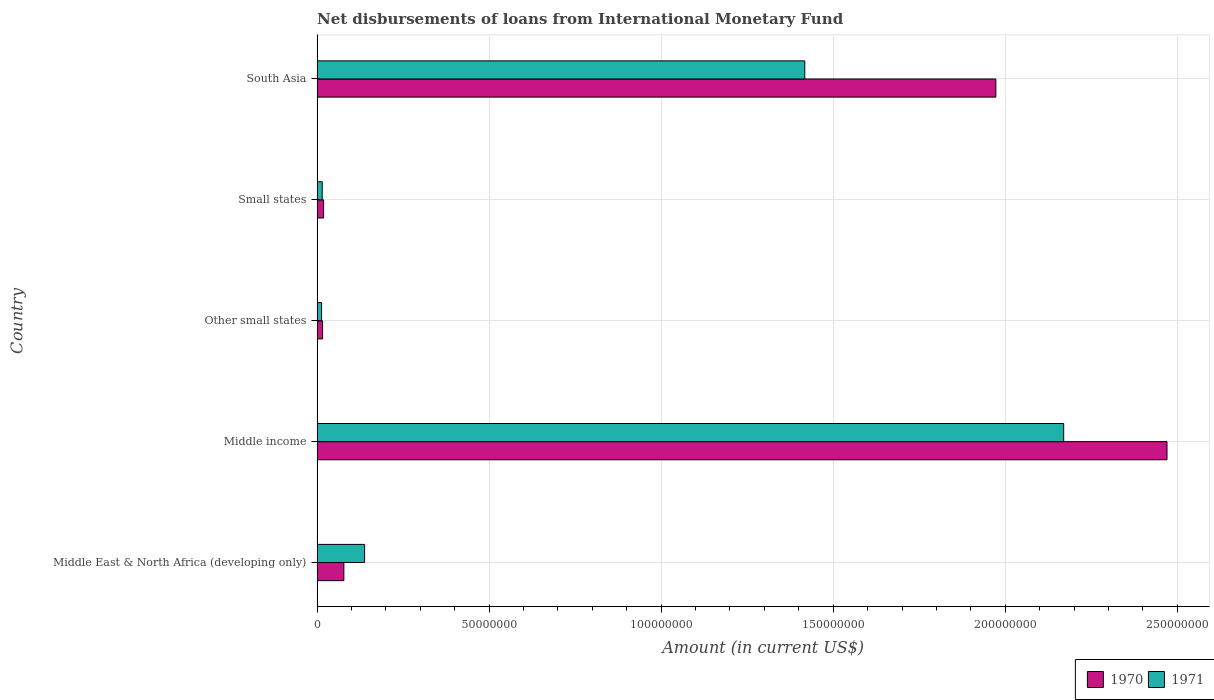In how many cases, is the number of bars for a given country not equal to the number of legend labels?
Provide a succinct answer. 0. What is the amount of loans disbursed in 1971 in Other small states?
Your answer should be compact. 1.32e+06. Across all countries, what is the maximum amount of loans disbursed in 1970?
Provide a short and direct response. 2.47e+08. Across all countries, what is the minimum amount of loans disbursed in 1970?
Your answer should be very brief. 1.61e+06. In which country was the amount of loans disbursed in 1971 maximum?
Your response must be concise. Middle income. In which country was the amount of loans disbursed in 1971 minimum?
Offer a terse response. Other small states. What is the total amount of loans disbursed in 1971 in the graph?
Keep it short and to the point. 3.75e+08. What is the difference between the amount of loans disbursed in 1971 in Middle East & North Africa (developing only) and that in Small states?
Ensure brevity in your answer.  1.23e+07. What is the difference between the amount of loans disbursed in 1970 in Middle income and the amount of loans disbursed in 1971 in Small states?
Offer a terse response. 2.46e+08. What is the average amount of loans disbursed in 1971 per country?
Your answer should be compact. 7.51e+07. What is the difference between the amount of loans disbursed in 1971 and amount of loans disbursed in 1970 in Middle East & North Africa (developing only)?
Ensure brevity in your answer.  6.03e+06. In how many countries, is the amount of loans disbursed in 1971 greater than 90000000 US$?
Give a very brief answer. 2. What is the ratio of the amount of loans disbursed in 1971 in Middle East & North Africa (developing only) to that in Small states?
Make the answer very short. 9.23. Is the difference between the amount of loans disbursed in 1971 in Middle East & North Africa (developing only) and South Asia greater than the difference between the amount of loans disbursed in 1970 in Middle East & North Africa (developing only) and South Asia?
Offer a very short reply. Yes. What is the difference between the highest and the second highest amount of loans disbursed in 1970?
Provide a succinct answer. 4.97e+07. What is the difference between the highest and the lowest amount of loans disbursed in 1970?
Ensure brevity in your answer.  2.45e+08. What does the 1st bar from the top in South Asia represents?
Your answer should be very brief. 1971. How many countries are there in the graph?
Your response must be concise. 5. What is the difference between two consecutive major ticks on the X-axis?
Offer a very short reply. 5.00e+07. Are the values on the major ticks of X-axis written in scientific E-notation?
Make the answer very short. No. Does the graph contain any zero values?
Offer a terse response. No. Does the graph contain grids?
Give a very brief answer. Yes. Where does the legend appear in the graph?
Offer a very short reply. Bottom right. How are the legend labels stacked?
Ensure brevity in your answer.  Horizontal. What is the title of the graph?
Your answer should be very brief. Net disbursements of loans from International Monetary Fund. Does "1986" appear as one of the legend labels in the graph?
Keep it short and to the point. No. What is the label or title of the X-axis?
Offer a terse response. Amount (in current US$). What is the Amount (in current US$) of 1970 in Middle East & North Africa (developing only)?
Ensure brevity in your answer.  7.79e+06. What is the Amount (in current US$) in 1971 in Middle East & North Africa (developing only)?
Your response must be concise. 1.38e+07. What is the Amount (in current US$) in 1970 in Middle income?
Provide a short and direct response. 2.47e+08. What is the Amount (in current US$) of 1971 in Middle income?
Keep it short and to the point. 2.17e+08. What is the Amount (in current US$) of 1970 in Other small states?
Offer a very short reply. 1.61e+06. What is the Amount (in current US$) in 1971 in Other small states?
Ensure brevity in your answer.  1.32e+06. What is the Amount (in current US$) in 1970 in Small states?
Your response must be concise. 1.91e+06. What is the Amount (in current US$) in 1971 in Small states?
Provide a succinct answer. 1.50e+06. What is the Amount (in current US$) in 1970 in South Asia?
Your answer should be very brief. 1.97e+08. What is the Amount (in current US$) in 1971 in South Asia?
Ensure brevity in your answer.  1.42e+08. Across all countries, what is the maximum Amount (in current US$) in 1970?
Give a very brief answer. 2.47e+08. Across all countries, what is the maximum Amount (in current US$) of 1971?
Offer a terse response. 2.17e+08. Across all countries, what is the minimum Amount (in current US$) of 1970?
Offer a terse response. 1.61e+06. Across all countries, what is the minimum Amount (in current US$) of 1971?
Offer a terse response. 1.32e+06. What is the total Amount (in current US$) in 1970 in the graph?
Ensure brevity in your answer.  4.56e+08. What is the total Amount (in current US$) in 1971 in the graph?
Your response must be concise. 3.75e+08. What is the difference between the Amount (in current US$) of 1970 in Middle East & North Africa (developing only) and that in Middle income?
Your answer should be compact. -2.39e+08. What is the difference between the Amount (in current US$) in 1971 in Middle East & North Africa (developing only) and that in Middle income?
Your answer should be very brief. -2.03e+08. What is the difference between the Amount (in current US$) of 1970 in Middle East & North Africa (developing only) and that in Other small states?
Provide a succinct answer. 6.19e+06. What is the difference between the Amount (in current US$) of 1971 in Middle East & North Africa (developing only) and that in Other small states?
Provide a short and direct response. 1.25e+07. What is the difference between the Amount (in current US$) of 1970 in Middle East & North Africa (developing only) and that in Small states?
Offer a very short reply. 5.89e+06. What is the difference between the Amount (in current US$) of 1971 in Middle East & North Africa (developing only) and that in Small states?
Ensure brevity in your answer.  1.23e+07. What is the difference between the Amount (in current US$) of 1970 in Middle East & North Africa (developing only) and that in South Asia?
Ensure brevity in your answer.  -1.89e+08. What is the difference between the Amount (in current US$) of 1971 in Middle East & North Africa (developing only) and that in South Asia?
Provide a succinct answer. -1.28e+08. What is the difference between the Amount (in current US$) in 1970 in Middle income and that in Other small states?
Provide a succinct answer. 2.45e+08. What is the difference between the Amount (in current US$) in 1971 in Middle income and that in Other small states?
Your answer should be very brief. 2.16e+08. What is the difference between the Amount (in current US$) in 1970 in Middle income and that in Small states?
Offer a very short reply. 2.45e+08. What is the difference between the Amount (in current US$) of 1971 in Middle income and that in Small states?
Provide a short and direct response. 2.15e+08. What is the difference between the Amount (in current US$) of 1970 in Middle income and that in South Asia?
Offer a terse response. 4.97e+07. What is the difference between the Amount (in current US$) in 1971 in Middle income and that in South Asia?
Offer a very short reply. 7.52e+07. What is the difference between the Amount (in current US$) in 1970 in Other small states and that in Small states?
Provide a short and direct response. -2.99e+05. What is the difference between the Amount (in current US$) of 1971 in Other small states and that in Small states?
Provide a short and direct response. -1.76e+05. What is the difference between the Amount (in current US$) in 1970 in Other small states and that in South Asia?
Make the answer very short. -1.96e+08. What is the difference between the Amount (in current US$) of 1971 in Other small states and that in South Asia?
Your answer should be very brief. -1.40e+08. What is the difference between the Amount (in current US$) of 1970 in Small states and that in South Asia?
Keep it short and to the point. -1.95e+08. What is the difference between the Amount (in current US$) in 1971 in Small states and that in South Asia?
Make the answer very short. -1.40e+08. What is the difference between the Amount (in current US$) of 1970 in Middle East & North Africa (developing only) and the Amount (in current US$) of 1971 in Middle income?
Ensure brevity in your answer.  -2.09e+08. What is the difference between the Amount (in current US$) in 1970 in Middle East & North Africa (developing only) and the Amount (in current US$) in 1971 in Other small states?
Offer a very short reply. 6.47e+06. What is the difference between the Amount (in current US$) in 1970 in Middle East & North Africa (developing only) and the Amount (in current US$) in 1971 in Small states?
Offer a terse response. 6.30e+06. What is the difference between the Amount (in current US$) of 1970 in Middle East & North Africa (developing only) and the Amount (in current US$) of 1971 in South Asia?
Give a very brief answer. -1.34e+08. What is the difference between the Amount (in current US$) in 1970 in Middle income and the Amount (in current US$) in 1971 in Other small states?
Make the answer very short. 2.46e+08. What is the difference between the Amount (in current US$) of 1970 in Middle income and the Amount (in current US$) of 1971 in Small states?
Offer a very short reply. 2.46e+08. What is the difference between the Amount (in current US$) of 1970 in Middle income and the Amount (in current US$) of 1971 in South Asia?
Offer a very short reply. 1.05e+08. What is the difference between the Amount (in current US$) of 1970 in Other small states and the Amount (in current US$) of 1971 in Small states?
Make the answer very short. 1.09e+05. What is the difference between the Amount (in current US$) in 1970 in Other small states and the Amount (in current US$) in 1971 in South Asia?
Offer a terse response. -1.40e+08. What is the difference between the Amount (in current US$) in 1970 in Small states and the Amount (in current US$) in 1971 in South Asia?
Provide a succinct answer. -1.40e+08. What is the average Amount (in current US$) in 1970 per country?
Make the answer very short. 9.11e+07. What is the average Amount (in current US$) of 1971 per country?
Offer a very short reply. 7.51e+07. What is the difference between the Amount (in current US$) of 1970 and Amount (in current US$) of 1971 in Middle East & North Africa (developing only)?
Ensure brevity in your answer.  -6.03e+06. What is the difference between the Amount (in current US$) of 1970 and Amount (in current US$) of 1971 in Middle income?
Make the answer very short. 3.00e+07. What is the difference between the Amount (in current US$) of 1970 and Amount (in current US$) of 1971 in Other small states?
Give a very brief answer. 2.85e+05. What is the difference between the Amount (in current US$) of 1970 and Amount (in current US$) of 1971 in Small states?
Your answer should be very brief. 4.08e+05. What is the difference between the Amount (in current US$) in 1970 and Amount (in current US$) in 1971 in South Asia?
Offer a terse response. 5.55e+07. What is the ratio of the Amount (in current US$) of 1970 in Middle East & North Africa (developing only) to that in Middle income?
Provide a succinct answer. 0.03. What is the ratio of the Amount (in current US$) of 1971 in Middle East & North Africa (developing only) to that in Middle income?
Ensure brevity in your answer.  0.06. What is the ratio of the Amount (in current US$) of 1970 in Middle East & North Africa (developing only) to that in Other small states?
Keep it short and to the point. 4.85. What is the ratio of the Amount (in current US$) of 1971 in Middle East & North Africa (developing only) to that in Other small states?
Your answer should be very brief. 10.45. What is the ratio of the Amount (in current US$) of 1970 in Middle East & North Africa (developing only) to that in Small states?
Provide a short and direct response. 4.09. What is the ratio of the Amount (in current US$) in 1971 in Middle East & North Africa (developing only) to that in Small states?
Make the answer very short. 9.23. What is the ratio of the Amount (in current US$) of 1970 in Middle East & North Africa (developing only) to that in South Asia?
Provide a short and direct response. 0.04. What is the ratio of the Amount (in current US$) in 1971 in Middle East & North Africa (developing only) to that in South Asia?
Make the answer very short. 0.1. What is the ratio of the Amount (in current US$) in 1970 in Middle income to that in Other small states?
Make the answer very short. 153.71. What is the ratio of the Amount (in current US$) of 1971 in Middle income to that in Other small states?
Make the answer very short. 164.14. What is the ratio of the Amount (in current US$) in 1970 in Middle income to that in Small states?
Your answer should be compact. 129.6. What is the ratio of the Amount (in current US$) in 1971 in Middle income to that in Small states?
Provide a short and direct response. 144.85. What is the ratio of the Amount (in current US$) in 1970 in Middle income to that in South Asia?
Give a very brief answer. 1.25. What is the ratio of the Amount (in current US$) of 1971 in Middle income to that in South Asia?
Provide a short and direct response. 1.53. What is the ratio of the Amount (in current US$) in 1970 in Other small states to that in Small states?
Your response must be concise. 0.84. What is the ratio of the Amount (in current US$) of 1971 in Other small states to that in Small states?
Your response must be concise. 0.88. What is the ratio of the Amount (in current US$) in 1970 in Other small states to that in South Asia?
Give a very brief answer. 0.01. What is the ratio of the Amount (in current US$) in 1971 in Other small states to that in South Asia?
Provide a short and direct response. 0.01. What is the ratio of the Amount (in current US$) in 1970 in Small states to that in South Asia?
Offer a very short reply. 0.01. What is the ratio of the Amount (in current US$) of 1971 in Small states to that in South Asia?
Your answer should be compact. 0.01. What is the difference between the highest and the second highest Amount (in current US$) of 1970?
Offer a very short reply. 4.97e+07. What is the difference between the highest and the second highest Amount (in current US$) in 1971?
Offer a terse response. 7.52e+07. What is the difference between the highest and the lowest Amount (in current US$) of 1970?
Offer a very short reply. 2.45e+08. What is the difference between the highest and the lowest Amount (in current US$) in 1971?
Ensure brevity in your answer.  2.16e+08. 